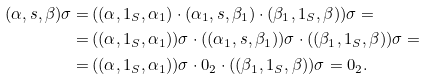<formula> <loc_0><loc_0><loc_500><loc_500>( \alpha , s , \beta ) \sigma = & \, ( ( \alpha , 1 _ { S } , \alpha _ { 1 } ) \cdot ( \alpha _ { 1 } , s , \beta _ { 1 } ) \cdot ( \beta _ { 1 } , 1 _ { S } , \beta ) ) \sigma = \\ = & \, ( ( \alpha , 1 _ { S } , \alpha _ { 1 } ) ) \sigma \cdot ( ( \alpha _ { 1 } , s , \beta _ { 1 } ) ) \sigma \cdot ( ( \beta _ { 1 } , 1 _ { S } , \beta ) ) \sigma = \\ = & \, ( ( \alpha , 1 _ { S } , \alpha _ { 1 } ) ) \sigma \cdot 0 _ { 2 } \cdot ( ( \beta _ { 1 } , 1 _ { S } , \beta ) ) \sigma = 0 _ { 2 } .</formula> 